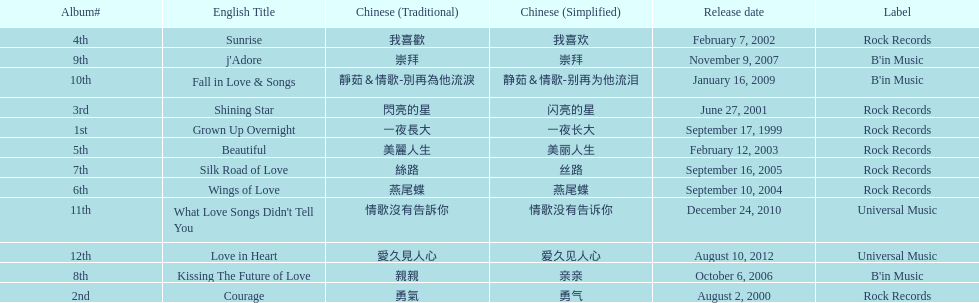Was the album beautiful released before the album love in heart? Yes. Write the full table. {'header': ['Album#', 'English Title', 'Chinese (Traditional)', 'Chinese (Simplified)', 'Release date', 'Label'], 'rows': [['4th', 'Sunrise', '我喜歡', '我喜欢', 'February 7, 2002', 'Rock Records'], ['9th', "j'Adore", '崇拜', '崇拜', 'November 9, 2007', "B'in Music"], ['10th', 'Fall in Love & Songs', '靜茹＆情歌-別再為他流淚', '静茹＆情歌-别再为他流泪', 'January 16, 2009', "B'in Music"], ['3rd', 'Shining Star', '閃亮的星', '闪亮的星', 'June 27, 2001', 'Rock Records'], ['1st', 'Grown Up Overnight', '一夜長大', '一夜长大', 'September 17, 1999', 'Rock Records'], ['5th', 'Beautiful', '美麗人生', '美丽人生', 'February 12, 2003', 'Rock Records'], ['7th', 'Silk Road of Love', '絲路', '丝路', 'September 16, 2005', 'Rock Records'], ['6th', 'Wings of Love', '燕尾蝶', '燕尾蝶', 'September 10, 2004', 'Rock Records'], ['11th', "What Love Songs Didn't Tell You", '情歌沒有告訴你', '情歌没有告诉你', 'December 24, 2010', 'Universal Music'], ['12th', 'Love in Heart', '愛久見人心', '爱久见人心', 'August 10, 2012', 'Universal Music'], ['8th', 'Kissing The Future of Love', '親親', '亲亲', 'October 6, 2006', "B'in Music"], ['2nd', 'Courage', '勇氣', '勇气', 'August 2, 2000', 'Rock Records']]} 